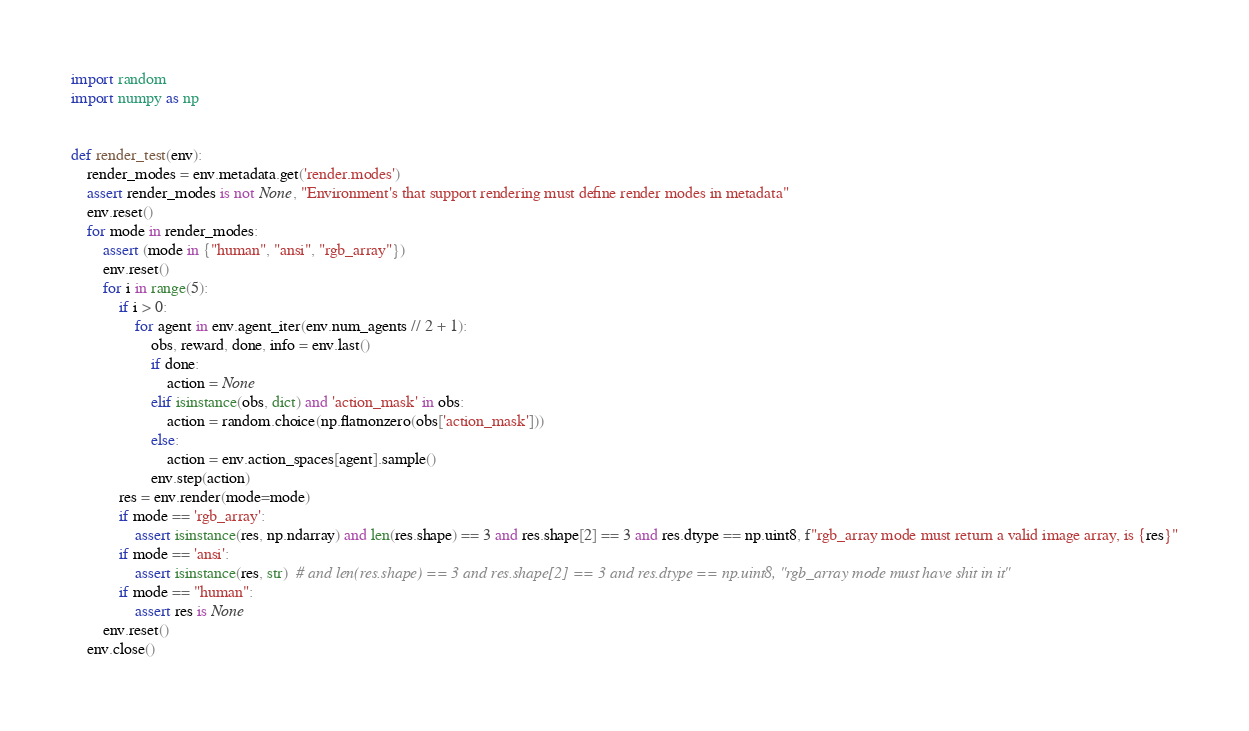<code> <loc_0><loc_0><loc_500><loc_500><_Python_>import random
import numpy as np


def render_test(env):
    render_modes = env.metadata.get('render.modes')
    assert render_modes is not None, "Environment's that support rendering must define render modes in metadata"
    env.reset()
    for mode in render_modes:
        assert (mode in {"human", "ansi", "rgb_array"})
        env.reset()
        for i in range(5):
            if i > 0:
                for agent in env.agent_iter(env.num_agents // 2 + 1):
                    obs, reward, done, info = env.last()
                    if done:
                        action = None
                    elif isinstance(obs, dict) and 'action_mask' in obs:
                        action = random.choice(np.flatnonzero(obs['action_mask']))
                    else:
                        action = env.action_spaces[agent].sample()
                    env.step(action)
            res = env.render(mode=mode)
            if mode == 'rgb_array':
                assert isinstance(res, np.ndarray) and len(res.shape) == 3 and res.shape[2] == 3 and res.dtype == np.uint8, f"rgb_array mode must return a valid image array, is {res}"
            if mode == 'ansi':
                assert isinstance(res, str)  # and len(res.shape) == 3 and res.shape[2] == 3 and res.dtype == np.uint8, "rgb_array mode must have shit in it"
            if mode == "human":
                assert res is None
        env.reset()
    env.close()
</code> 